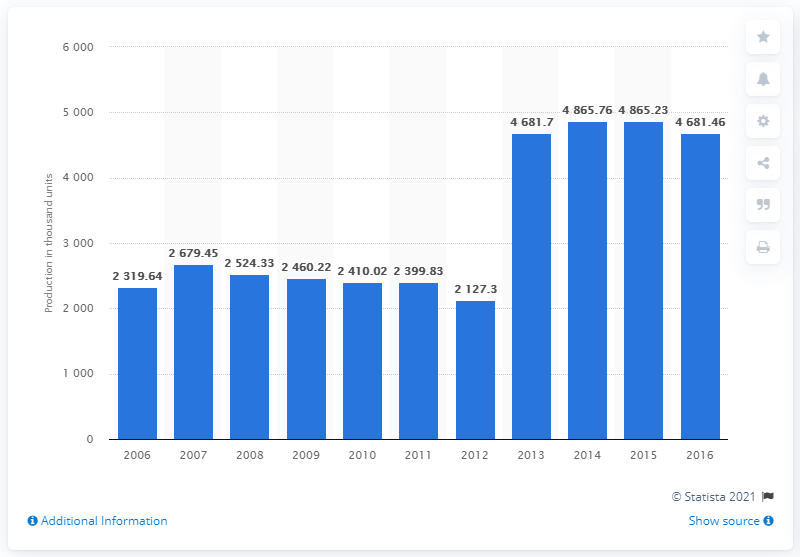Outline some significant characteristics in this image. In the year 2013, Chrysler became a subsidiary of Fiat Chrysler Automobiles. 